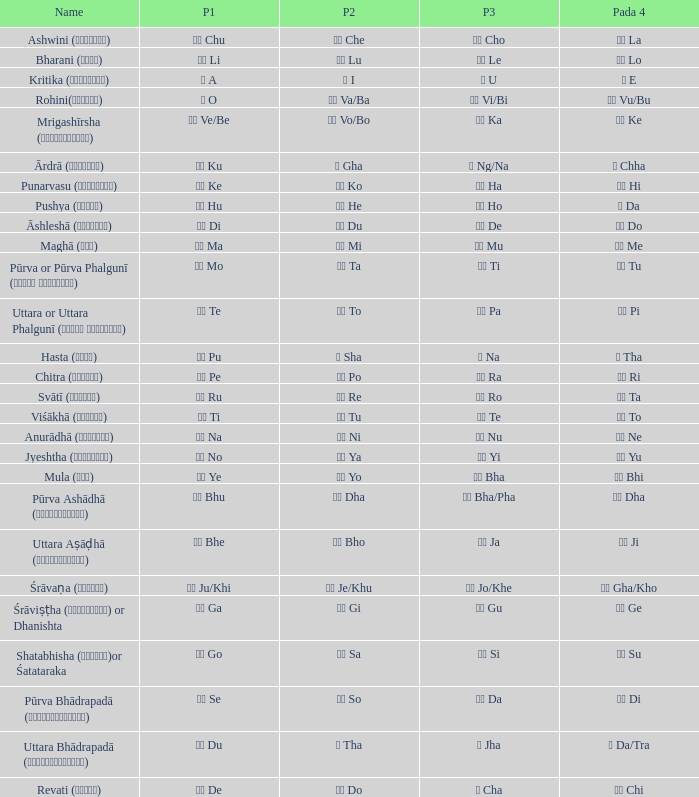Which Pada 3 has a Pada 1 of टे te? पा Pa. 